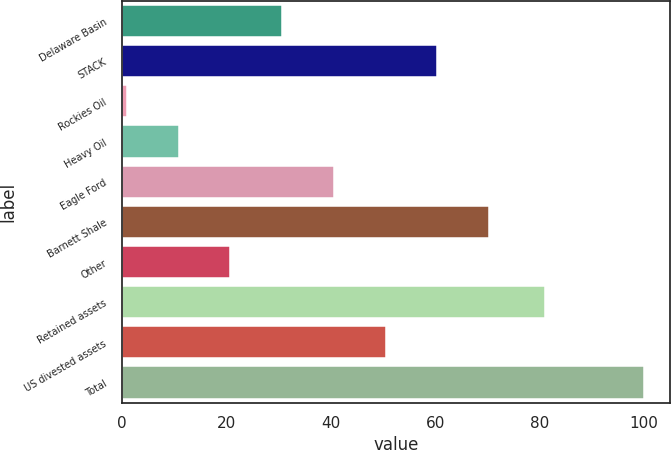<chart> <loc_0><loc_0><loc_500><loc_500><bar_chart><fcel>Delaware Basin<fcel>STACK<fcel>Rockies Oil<fcel>Heavy Oil<fcel>Eagle Ford<fcel>Barnett Shale<fcel>Other<fcel>Retained assets<fcel>US divested assets<fcel>Total<nl><fcel>30.7<fcel>60.4<fcel>1<fcel>10.9<fcel>40.6<fcel>70.3<fcel>20.8<fcel>81<fcel>50.5<fcel>100<nl></chart> 